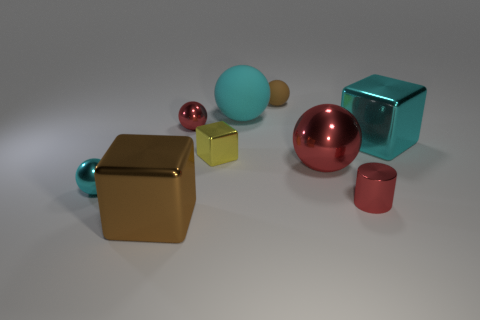Subtract all brown rubber balls. How many balls are left? 4 Subtract all red cylinders. How many cyan spheres are left? 2 Subtract all brown cubes. How many cubes are left? 2 Subtract 1 cubes. How many cubes are left? 2 Add 1 yellow shiny objects. How many objects exist? 10 Subtract all spheres. How many objects are left? 4 Subtract all cyan blocks. Subtract all big cyan cubes. How many objects are left? 7 Add 1 brown shiny things. How many brown shiny things are left? 2 Add 4 small matte balls. How many small matte balls exist? 5 Subtract 1 red cylinders. How many objects are left? 8 